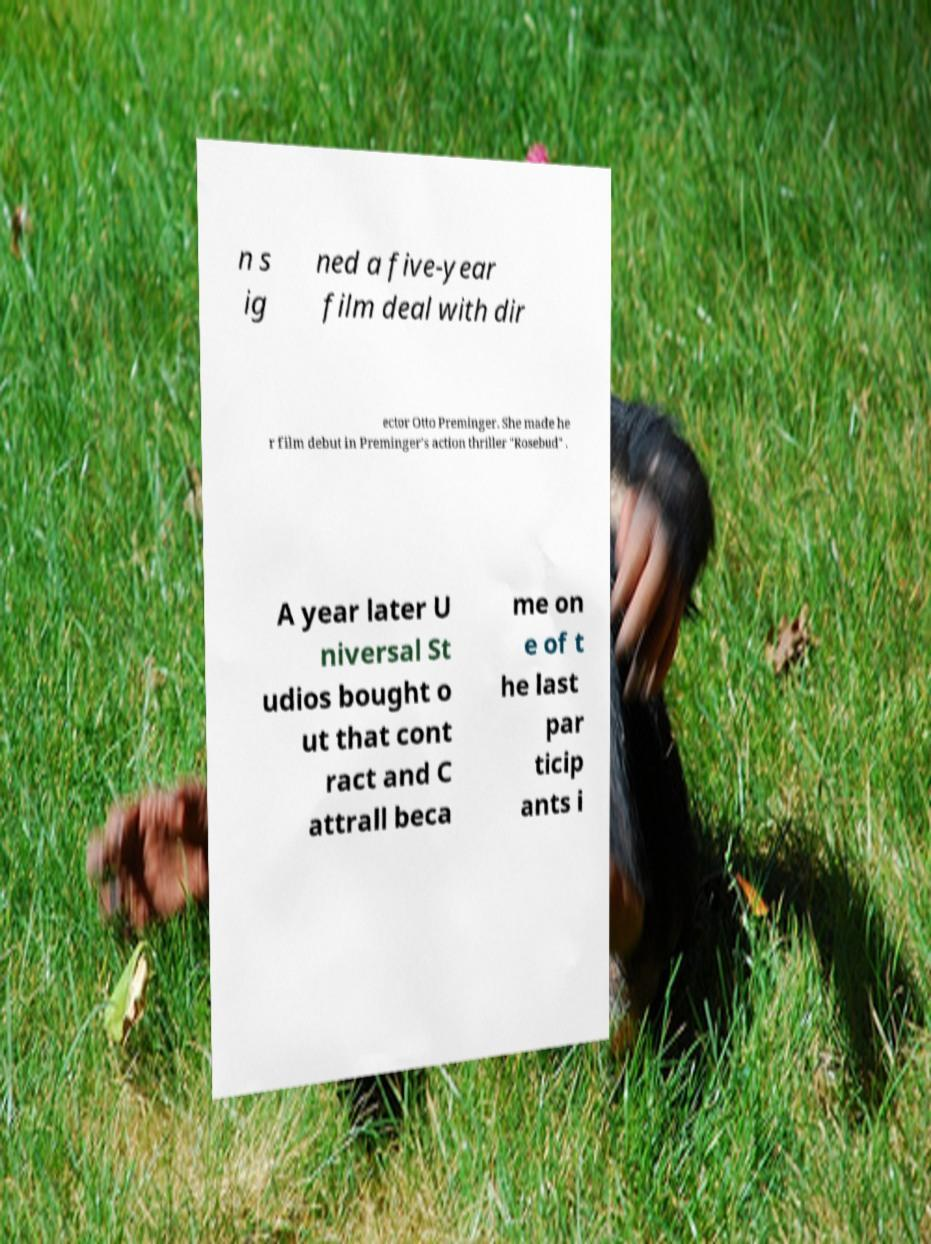What messages or text are displayed in this image? I need them in a readable, typed format. n s ig ned a five-year film deal with dir ector Otto Preminger. She made he r film debut in Preminger's action thriller "Rosebud" . A year later U niversal St udios bought o ut that cont ract and C attrall beca me on e of t he last par ticip ants i 